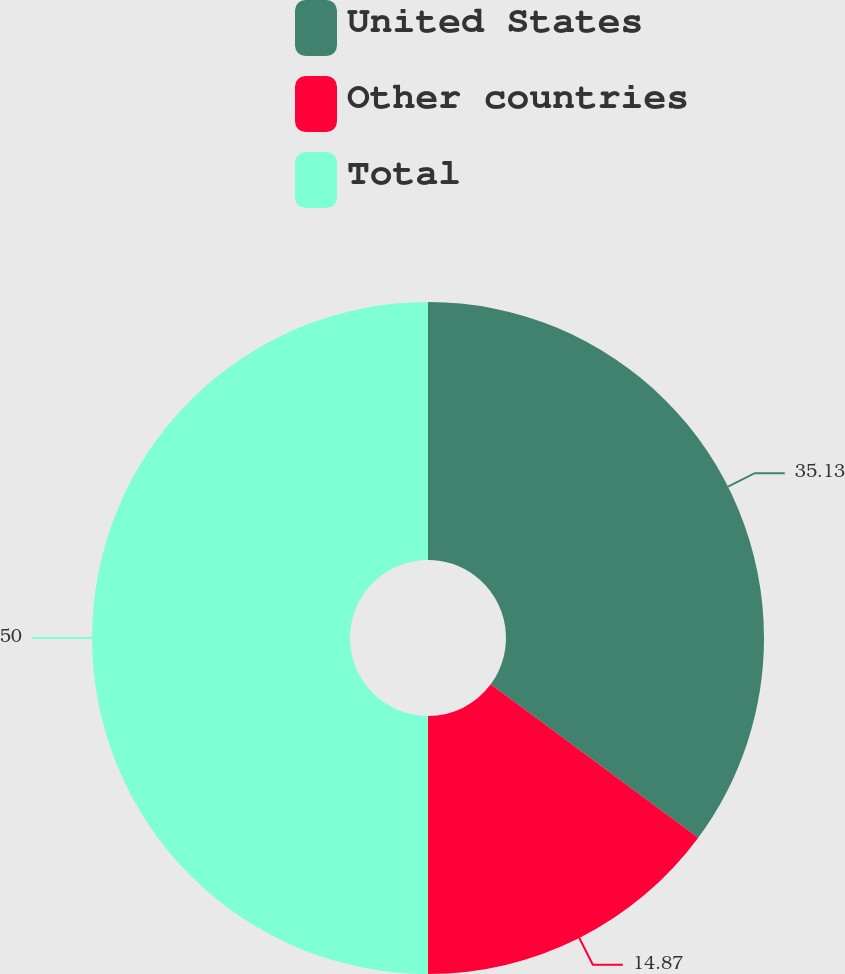<chart> <loc_0><loc_0><loc_500><loc_500><pie_chart><fcel>United States<fcel>Other countries<fcel>Total<nl><fcel>35.13%<fcel>14.87%<fcel>50.0%<nl></chart> 